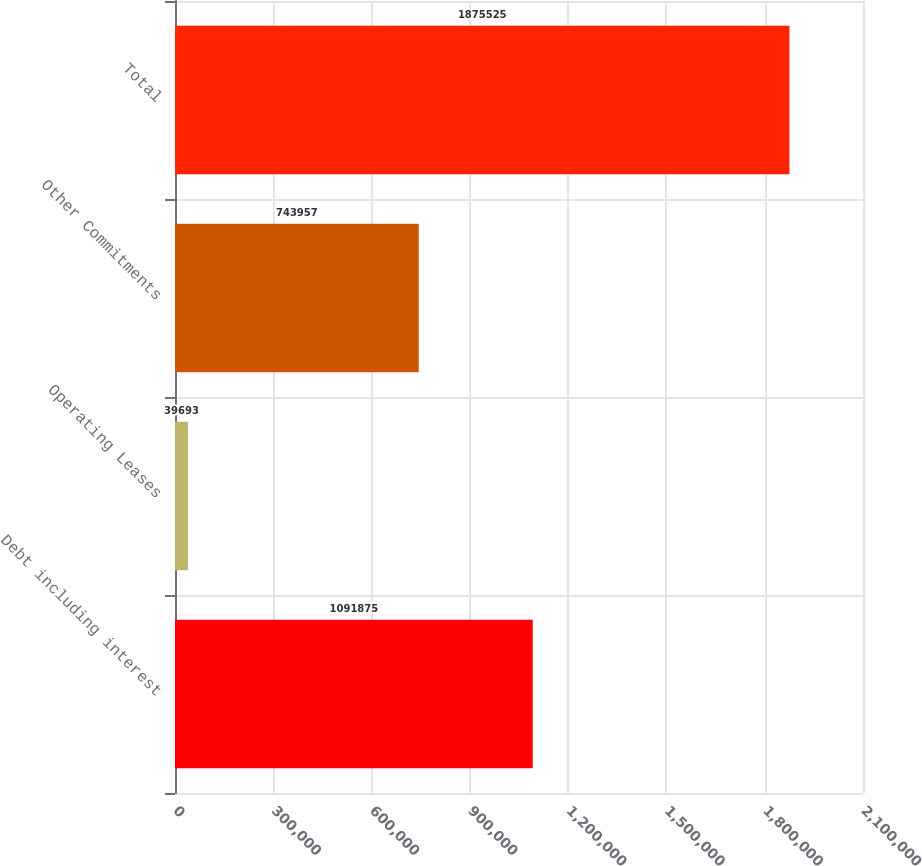Convert chart to OTSL. <chart><loc_0><loc_0><loc_500><loc_500><bar_chart><fcel>Debt including interest<fcel>Operating Leases<fcel>Other Commitments<fcel>Total<nl><fcel>1.09188e+06<fcel>39693<fcel>743957<fcel>1.87552e+06<nl></chart> 